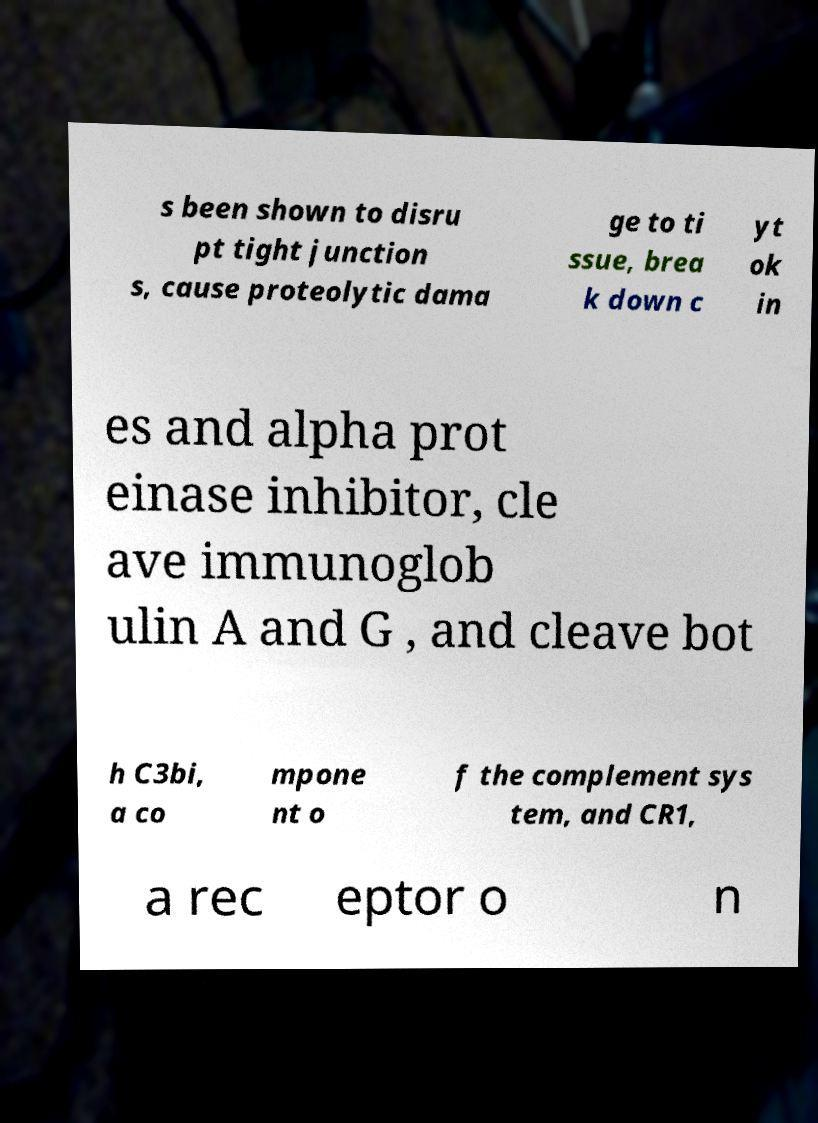Could you extract and type out the text from this image? s been shown to disru pt tight junction s, cause proteolytic dama ge to ti ssue, brea k down c yt ok in es and alpha prot einase inhibitor, cle ave immunoglob ulin A and G , and cleave bot h C3bi, a co mpone nt o f the complement sys tem, and CR1, a rec eptor o n 